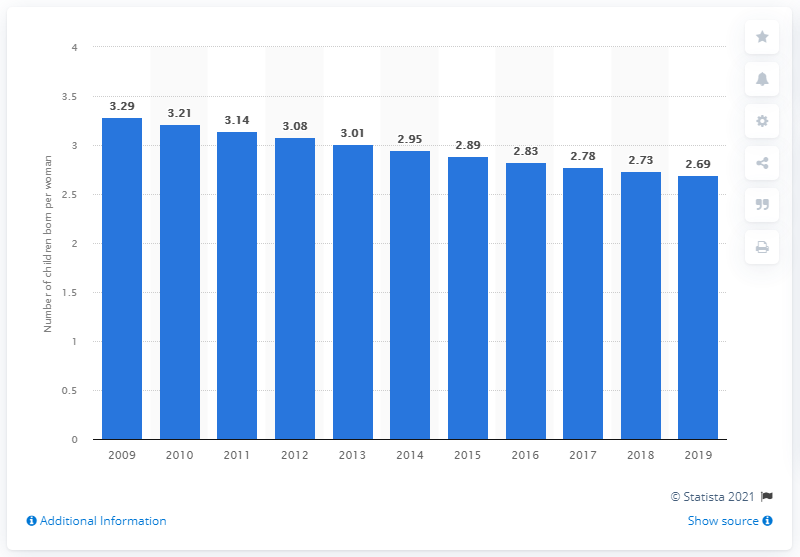Mention a couple of crucial points in this snapshot. In 2019, Bolivia's fertility rate was 2.69. 